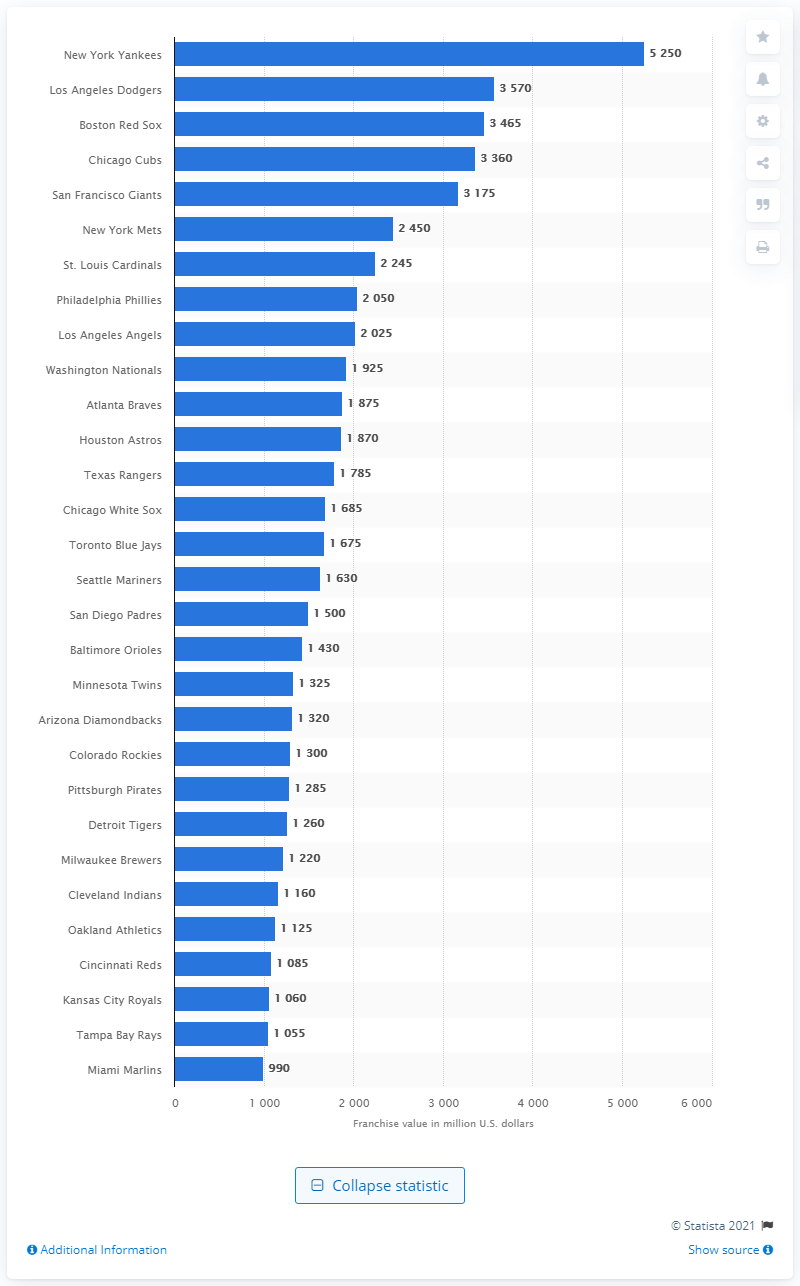List a handful of essential elements in this visual. As of 2021, the Houston Astros franchise was valued at a significant amount of dollars in the year 1875. 